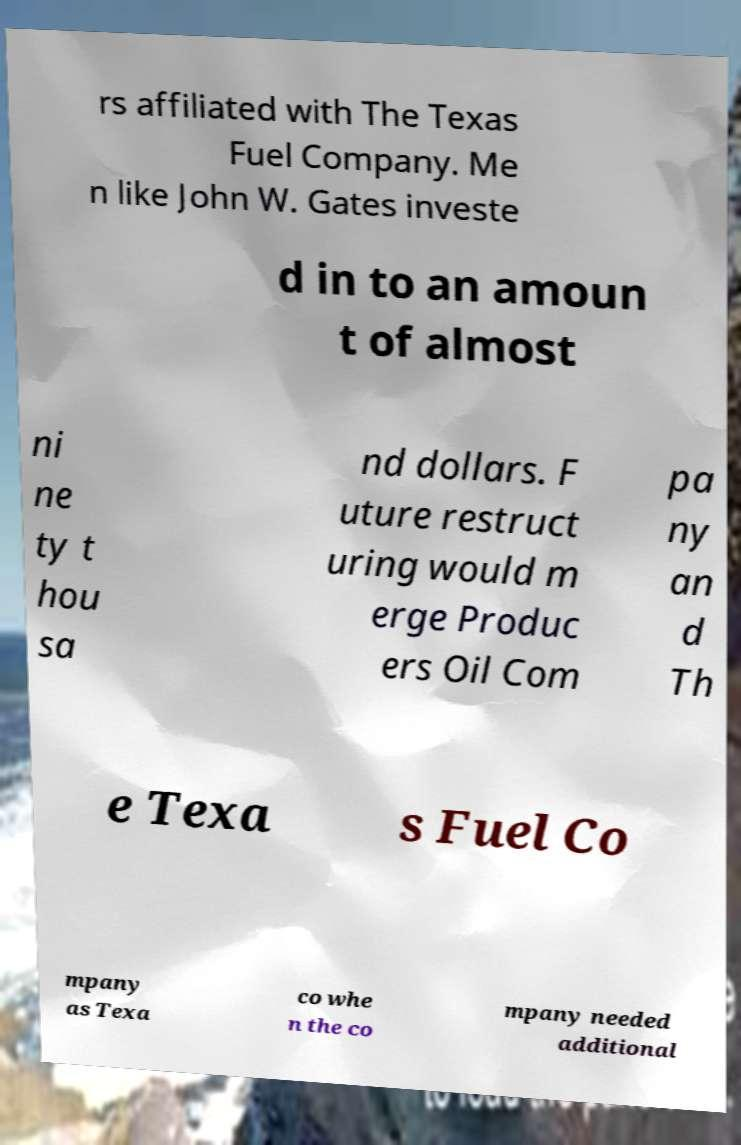Can you accurately transcribe the text from the provided image for me? rs affiliated with The Texas Fuel Company. Me n like John W. Gates investe d in to an amoun t of almost ni ne ty t hou sa nd dollars. F uture restruct uring would m erge Produc ers Oil Com pa ny an d Th e Texa s Fuel Co mpany as Texa co whe n the co mpany needed additional 